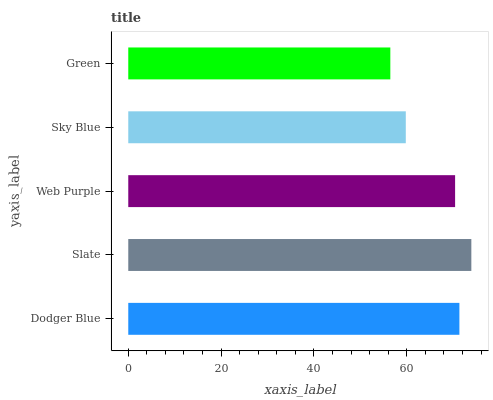Is Green the minimum?
Answer yes or no. Yes. Is Slate the maximum?
Answer yes or no. Yes. Is Web Purple the minimum?
Answer yes or no. No. Is Web Purple the maximum?
Answer yes or no. No. Is Slate greater than Web Purple?
Answer yes or no. Yes. Is Web Purple less than Slate?
Answer yes or no. Yes. Is Web Purple greater than Slate?
Answer yes or no. No. Is Slate less than Web Purple?
Answer yes or no. No. Is Web Purple the high median?
Answer yes or no. Yes. Is Web Purple the low median?
Answer yes or no. Yes. Is Sky Blue the high median?
Answer yes or no. No. Is Sky Blue the low median?
Answer yes or no. No. 